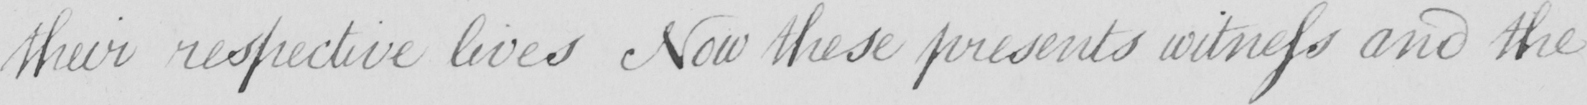What is written in this line of handwriting? their respective lives Now these presents witness and the 